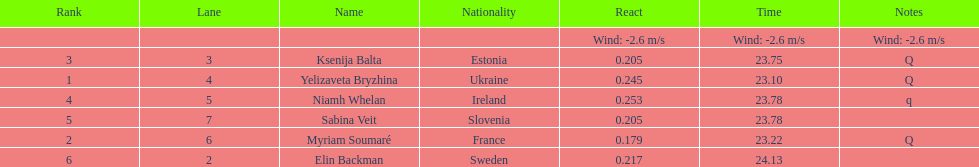Who finished after sabina veit? Elin Backman. 